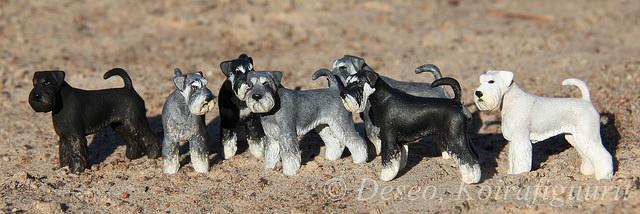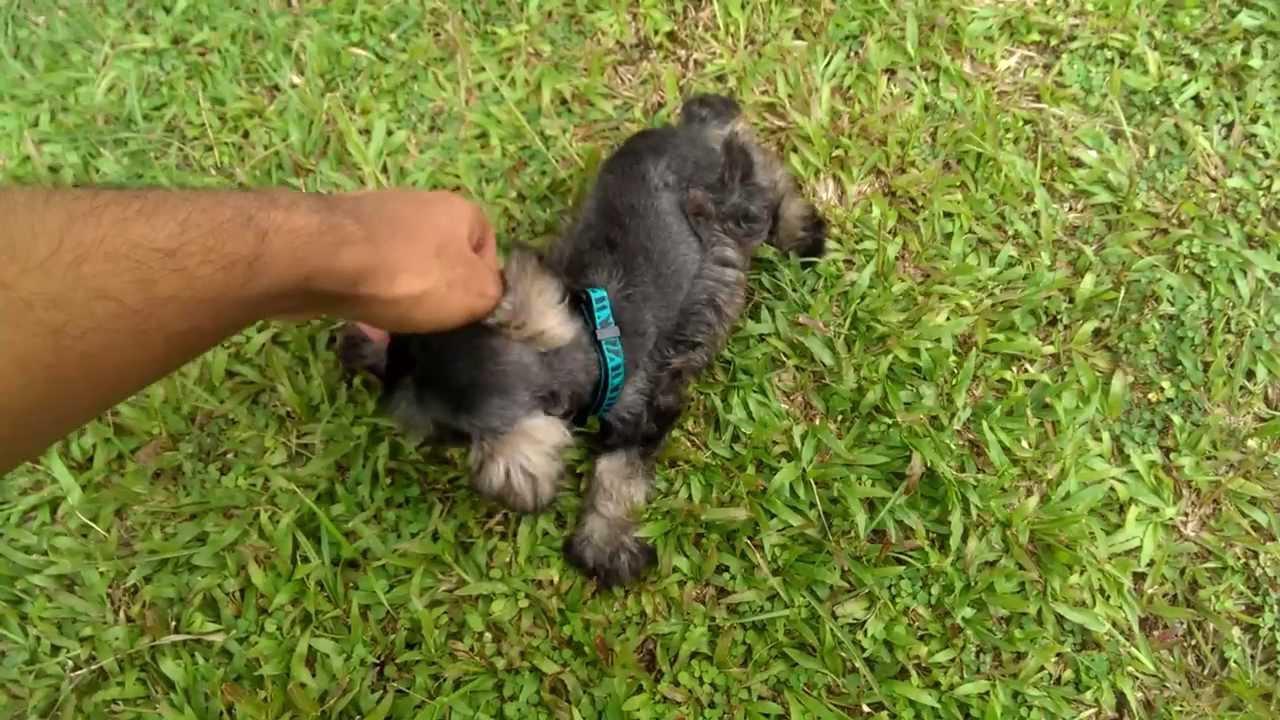The first image is the image on the left, the second image is the image on the right. Evaluate the accuracy of this statement regarding the images: "Right image shows a group of schnauzers wearing colored collars.". Is it true? Answer yes or no. No. The first image is the image on the left, the second image is the image on the right. For the images displayed, is the sentence "A group of dogs is in the green grass in the image on the right." factually correct? Answer yes or no. No. 